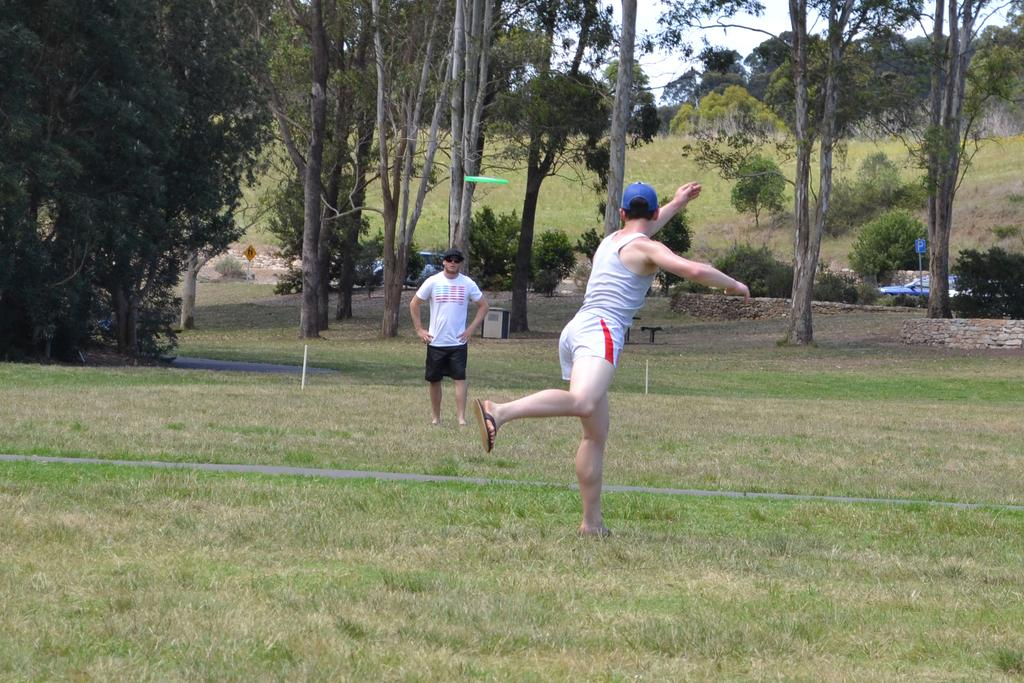How many people are in the image? There are two persons in the image. What are the persons wearing on their heads? The persons are wearing caps. Where are the persons standing in the image? The persons are standing on the grass. What type of vegetation can be seen in the image? There are trees and plants in the image. What is the ground surface like in the image? There is grass visible in the image. What part of the natural environment is visible in the image? The sky is visible in the image. What time of day does the laborer take a break in the image? There is no laborer present in the image, and therefore no information about a break can be determined. 